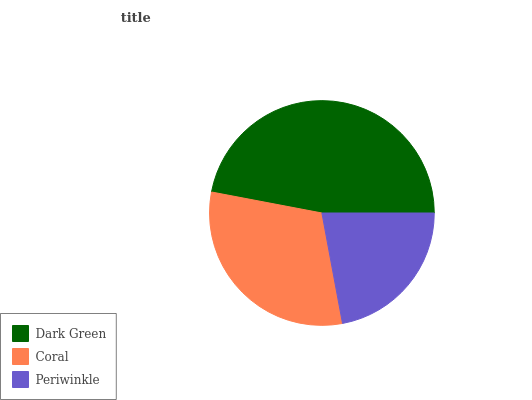Is Periwinkle the minimum?
Answer yes or no. Yes. Is Dark Green the maximum?
Answer yes or no. Yes. Is Coral the minimum?
Answer yes or no. No. Is Coral the maximum?
Answer yes or no. No. Is Dark Green greater than Coral?
Answer yes or no. Yes. Is Coral less than Dark Green?
Answer yes or no. Yes. Is Coral greater than Dark Green?
Answer yes or no. No. Is Dark Green less than Coral?
Answer yes or no. No. Is Coral the high median?
Answer yes or no. Yes. Is Coral the low median?
Answer yes or no. Yes. Is Periwinkle the high median?
Answer yes or no. No. Is Periwinkle the low median?
Answer yes or no. No. 